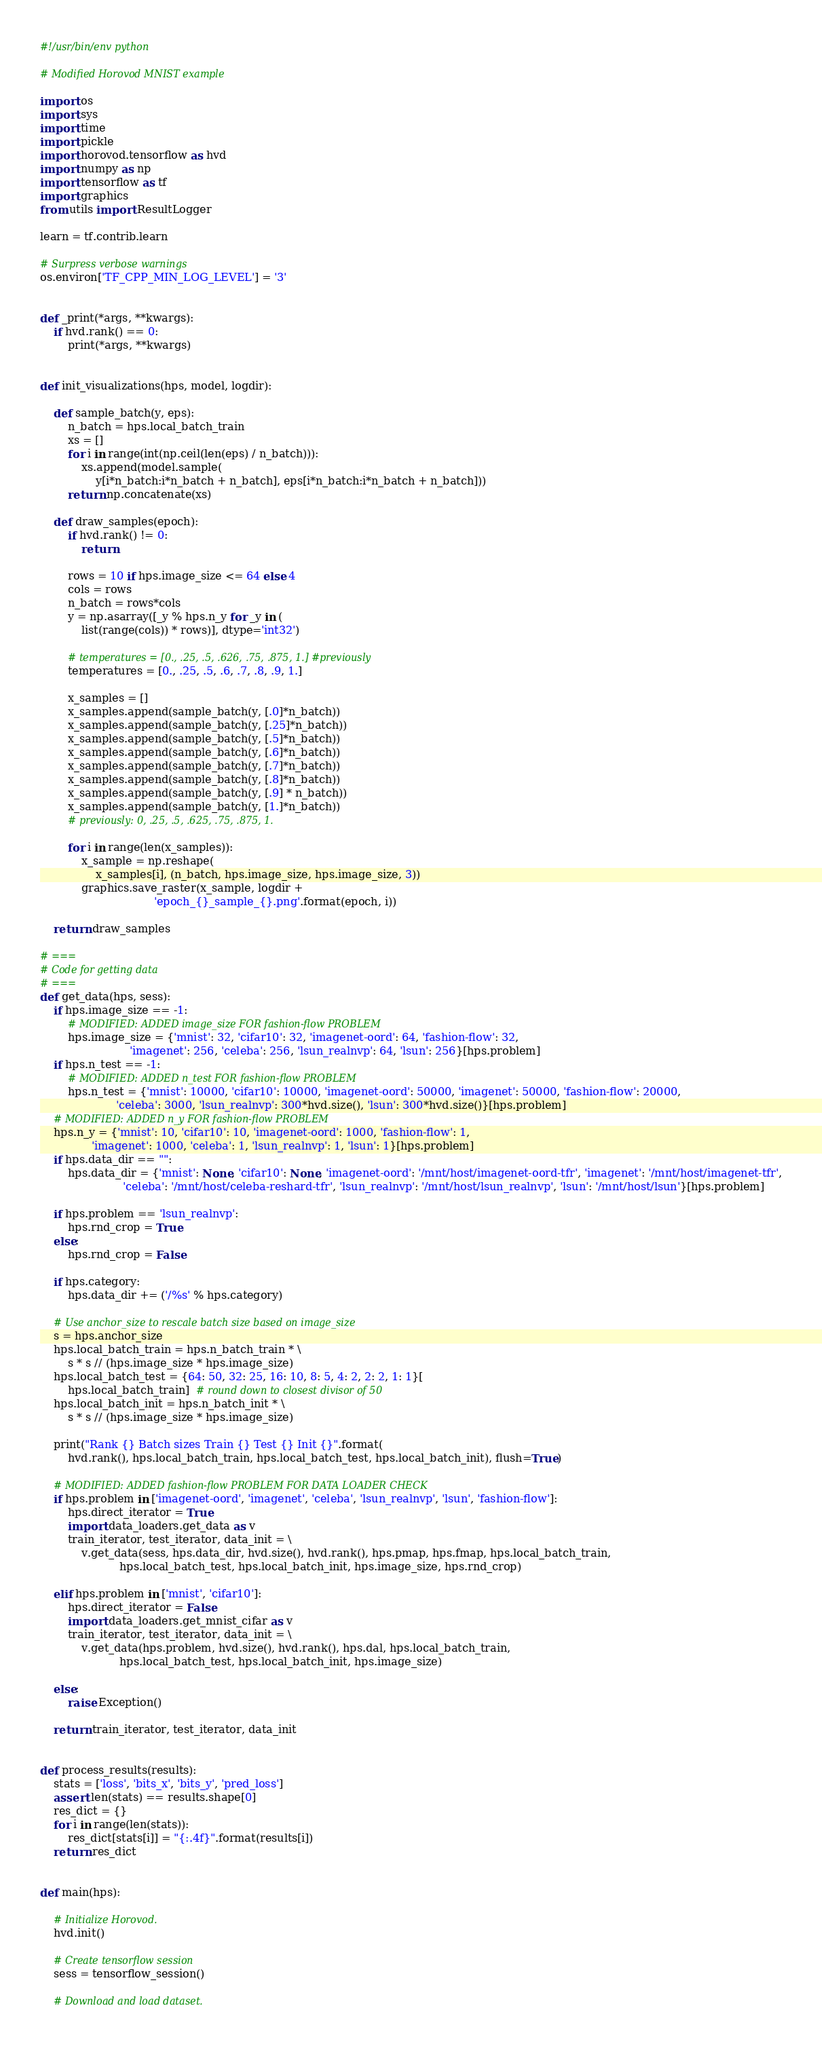<code> <loc_0><loc_0><loc_500><loc_500><_Python_>#!/usr/bin/env python

# Modified Horovod MNIST example

import os
import sys
import time
import pickle
import horovod.tensorflow as hvd
import numpy as np
import tensorflow as tf
import graphics
from utils import ResultLogger

learn = tf.contrib.learn

# Surpress verbose warnings
os.environ['TF_CPP_MIN_LOG_LEVEL'] = '3'


def _print(*args, **kwargs):
    if hvd.rank() == 0:
        print(*args, **kwargs)


def init_visualizations(hps, model, logdir):

    def sample_batch(y, eps):
        n_batch = hps.local_batch_train
        xs = []
        for i in range(int(np.ceil(len(eps) / n_batch))):
            xs.append(model.sample(
                y[i*n_batch:i*n_batch + n_batch], eps[i*n_batch:i*n_batch + n_batch]))
        return np.concatenate(xs)

    def draw_samples(epoch):
        if hvd.rank() != 0:
            return

        rows = 10 if hps.image_size <= 64 else 4
        cols = rows
        n_batch = rows*cols
        y = np.asarray([_y % hps.n_y for _y in (
            list(range(cols)) * rows)], dtype='int32')

        # temperatures = [0., .25, .5, .626, .75, .875, 1.] #previously
        temperatures = [0., .25, .5, .6, .7, .8, .9, 1.]

        x_samples = []
        x_samples.append(sample_batch(y, [.0]*n_batch))
        x_samples.append(sample_batch(y, [.25]*n_batch))
        x_samples.append(sample_batch(y, [.5]*n_batch))
        x_samples.append(sample_batch(y, [.6]*n_batch))
        x_samples.append(sample_batch(y, [.7]*n_batch))
        x_samples.append(sample_batch(y, [.8]*n_batch))
        x_samples.append(sample_batch(y, [.9] * n_batch))
        x_samples.append(sample_batch(y, [1.]*n_batch))
        # previously: 0, .25, .5, .625, .75, .875, 1.

        for i in range(len(x_samples)):
            x_sample = np.reshape(
                x_samples[i], (n_batch, hps.image_size, hps.image_size, 3))
            graphics.save_raster(x_sample, logdir +
                                 'epoch_{}_sample_{}.png'.format(epoch, i))

    return draw_samples

# ===
# Code for getting data
# ===
def get_data(hps, sess):
    if hps.image_size == -1:
        # MODIFIED: ADDED image_size FOR fashion-flow PROBLEM
        hps.image_size = {'mnist': 32, 'cifar10': 32, 'imagenet-oord': 64, 'fashion-flow': 32,
                          'imagenet': 256, 'celeba': 256, 'lsun_realnvp': 64, 'lsun': 256}[hps.problem]
    if hps.n_test == -1:
        # MODIFIED: ADDED n_test FOR fashion-flow PROBLEM
        hps.n_test = {'mnist': 10000, 'cifar10': 10000, 'imagenet-oord': 50000, 'imagenet': 50000, 'fashion-flow': 20000,
                      'celeba': 3000, 'lsun_realnvp': 300*hvd.size(), 'lsun': 300*hvd.size()}[hps.problem]
    # MODIFIED: ADDED n_y FOR fashion-flow PROBLEM
    hps.n_y = {'mnist': 10, 'cifar10': 10, 'imagenet-oord': 1000, 'fashion-flow': 1,
               'imagenet': 1000, 'celeba': 1, 'lsun_realnvp': 1, 'lsun': 1}[hps.problem]
    if hps.data_dir == "":
        hps.data_dir = {'mnist': None, 'cifar10': None, 'imagenet-oord': '/mnt/host/imagenet-oord-tfr', 'imagenet': '/mnt/host/imagenet-tfr',
                        'celeba': '/mnt/host/celeba-reshard-tfr', 'lsun_realnvp': '/mnt/host/lsun_realnvp', 'lsun': '/mnt/host/lsun'}[hps.problem]

    if hps.problem == 'lsun_realnvp':
        hps.rnd_crop = True
    else:
        hps.rnd_crop = False

    if hps.category:
        hps.data_dir += ('/%s' % hps.category)

    # Use anchor_size to rescale batch size based on image_size
    s = hps.anchor_size
    hps.local_batch_train = hps.n_batch_train * \
        s * s // (hps.image_size * hps.image_size)
    hps.local_batch_test = {64: 50, 32: 25, 16: 10, 8: 5, 4: 2, 2: 2, 1: 1}[
        hps.local_batch_train]  # round down to closest divisor of 50
    hps.local_batch_init = hps.n_batch_init * \
        s * s // (hps.image_size * hps.image_size)

    print("Rank {} Batch sizes Train {} Test {} Init {}".format(
        hvd.rank(), hps.local_batch_train, hps.local_batch_test, hps.local_batch_init), flush=True)

    # MODIFIED: ADDED fashion-flow PROBLEM FOR DATA LOADER CHECK
    if hps.problem in ['imagenet-oord', 'imagenet', 'celeba', 'lsun_realnvp', 'lsun', 'fashion-flow']:
        hps.direct_iterator = True
        import data_loaders.get_data as v
        train_iterator, test_iterator, data_init = \
            v.get_data(sess, hps.data_dir, hvd.size(), hvd.rank(), hps.pmap, hps.fmap, hps.local_batch_train,
                       hps.local_batch_test, hps.local_batch_init, hps.image_size, hps.rnd_crop)

    elif hps.problem in ['mnist', 'cifar10']:
        hps.direct_iterator = False
        import data_loaders.get_mnist_cifar as v
        train_iterator, test_iterator, data_init = \
            v.get_data(hps.problem, hvd.size(), hvd.rank(), hps.dal, hps.local_batch_train,
                       hps.local_batch_test, hps.local_batch_init, hps.image_size)

    else:
        raise Exception()

    return train_iterator, test_iterator, data_init


def process_results(results):
    stats = ['loss', 'bits_x', 'bits_y', 'pred_loss']
    assert len(stats) == results.shape[0]
    res_dict = {}
    for i in range(len(stats)):
        res_dict[stats[i]] = "{:.4f}".format(results[i])
    return res_dict


def main(hps):

    # Initialize Horovod.
    hvd.init()

    # Create tensorflow session
    sess = tensorflow_session()

    # Download and load dataset.</code> 